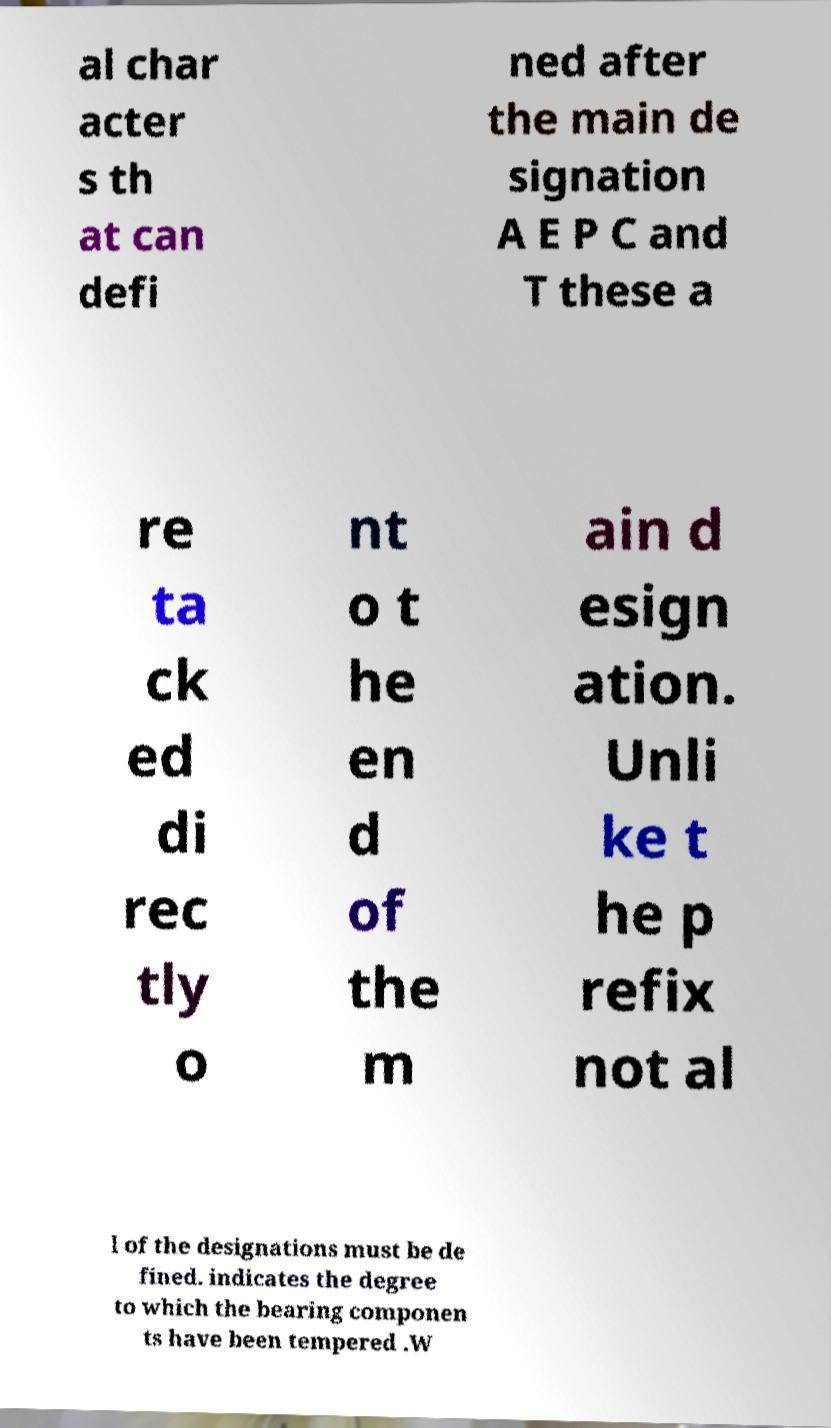For documentation purposes, I need the text within this image transcribed. Could you provide that? al char acter s th at can defi ned after the main de signation A E P C and T these a re ta ck ed di rec tly o nt o t he en d of the m ain d esign ation. Unli ke t he p refix not al l of the designations must be de fined. indicates the degree to which the bearing componen ts have been tempered .W 